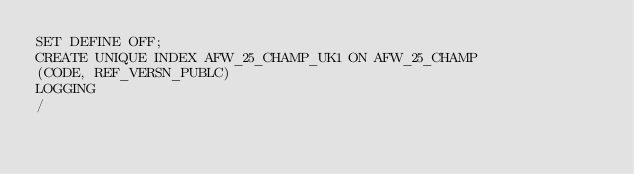<code> <loc_0><loc_0><loc_500><loc_500><_SQL_>SET DEFINE OFF;
CREATE UNIQUE INDEX AFW_25_CHAMP_UK1 ON AFW_25_CHAMP
(CODE, REF_VERSN_PUBLC)
LOGGING
/
</code> 